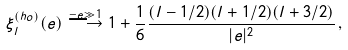Convert formula to latex. <formula><loc_0><loc_0><loc_500><loc_500>\xi ^ { ( h o ) } _ { l } ( e ) \stackrel { - e \gg 1 } { \longrightarrow } 1 + \frac { 1 } { 6 } \frac { ( l - 1 / 2 ) ( l + 1 / 2 ) ( l + 3 / 2 ) } { | e | ^ { 2 } } \, ,</formula> 